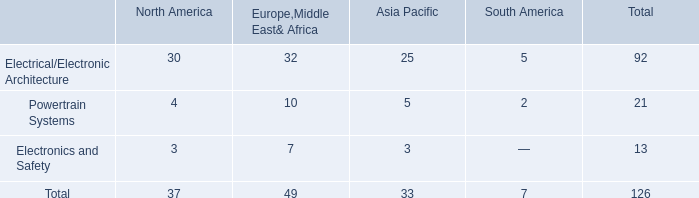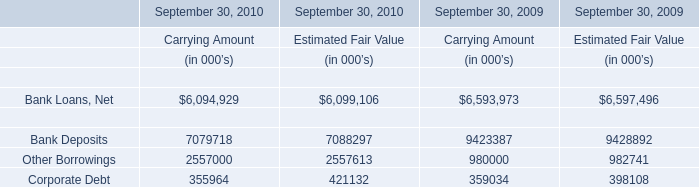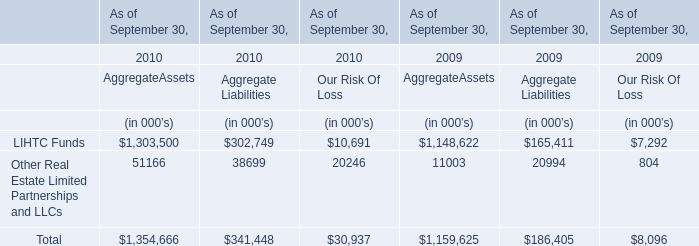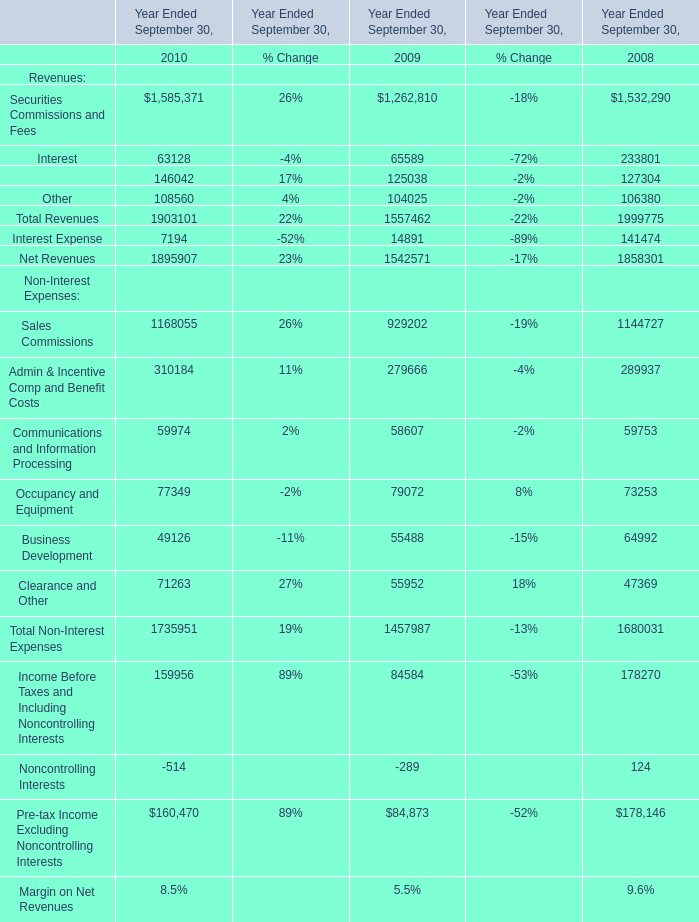What is the sum of the Total Revenues in the years where Securities Commissions and Fees greater than 1500000? 
Computations: (1903101 + 1999775)
Answer: 3902876.0. 